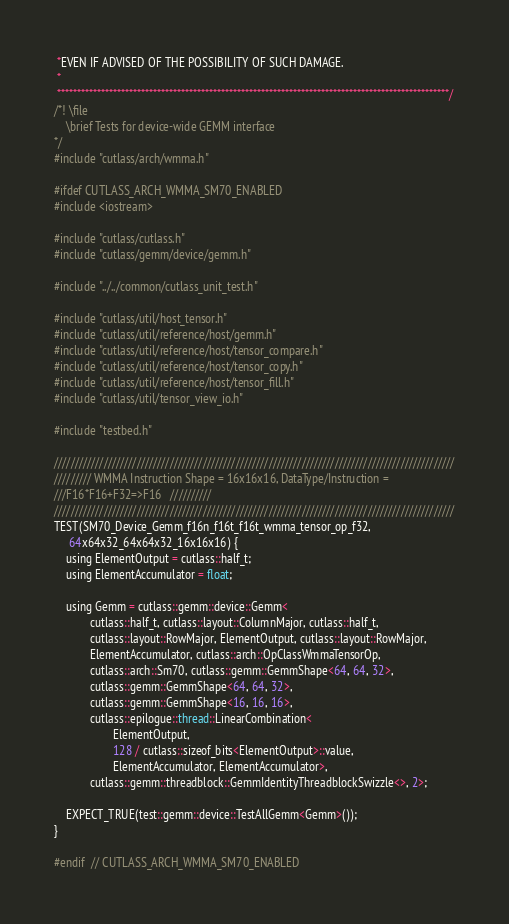<code> <loc_0><loc_0><loc_500><loc_500><_Cuda_> *EVEN IF ADVISED OF THE POSSIBILITY OF SUCH DAMAGE.
 *
 **************************************************************************************************/
/*! \file
    \brief Tests for device-wide GEMM interface
*/
#include "cutlass/arch/wmma.h"

#ifdef CUTLASS_ARCH_WMMA_SM70_ENABLED
#include <iostream>

#include "cutlass/cutlass.h"
#include "cutlass/gemm/device/gemm.h"

#include "../../common/cutlass_unit_test.h"

#include "cutlass/util/host_tensor.h"
#include "cutlass/util/reference/host/gemm.h"
#include "cutlass/util/reference/host/tensor_compare.h"
#include "cutlass/util/reference/host/tensor_copy.h"
#include "cutlass/util/reference/host/tensor_fill.h"
#include "cutlass/util/tensor_view_io.h"

#include "testbed.h"

/////////////////////////////////////////////////////////////////////////////////////////////////
///////// WMMA Instruction Shape = 16x16x16, DataType/Instruction =
///F16*F16+F32=>F16   //////////
/////////////////////////////////////////////////////////////////////////////////////////////////
TEST(SM70_Device_Gemm_f16n_f16t_f16t_wmma_tensor_op_f32,
     64x64x32_64x64x32_16x16x16) {
    using ElementOutput = cutlass::half_t;
    using ElementAccumulator = float;

    using Gemm = cutlass::gemm::device::Gemm<
            cutlass::half_t, cutlass::layout::ColumnMajor, cutlass::half_t,
            cutlass::layout::RowMajor, ElementOutput, cutlass::layout::RowMajor,
            ElementAccumulator, cutlass::arch::OpClassWmmaTensorOp,
            cutlass::arch::Sm70, cutlass::gemm::GemmShape<64, 64, 32>,
            cutlass::gemm::GemmShape<64, 64, 32>,
            cutlass::gemm::GemmShape<16, 16, 16>,
            cutlass::epilogue::thread::LinearCombination<
                    ElementOutput,
                    128 / cutlass::sizeof_bits<ElementOutput>::value,
                    ElementAccumulator, ElementAccumulator>,
            cutlass::gemm::threadblock::GemmIdentityThreadblockSwizzle<>, 2>;

    EXPECT_TRUE(test::gemm::device::TestAllGemm<Gemm>());
}

#endif  // CUTLASS_ARCH_WMMA_SM70_ENABLED
</code> 